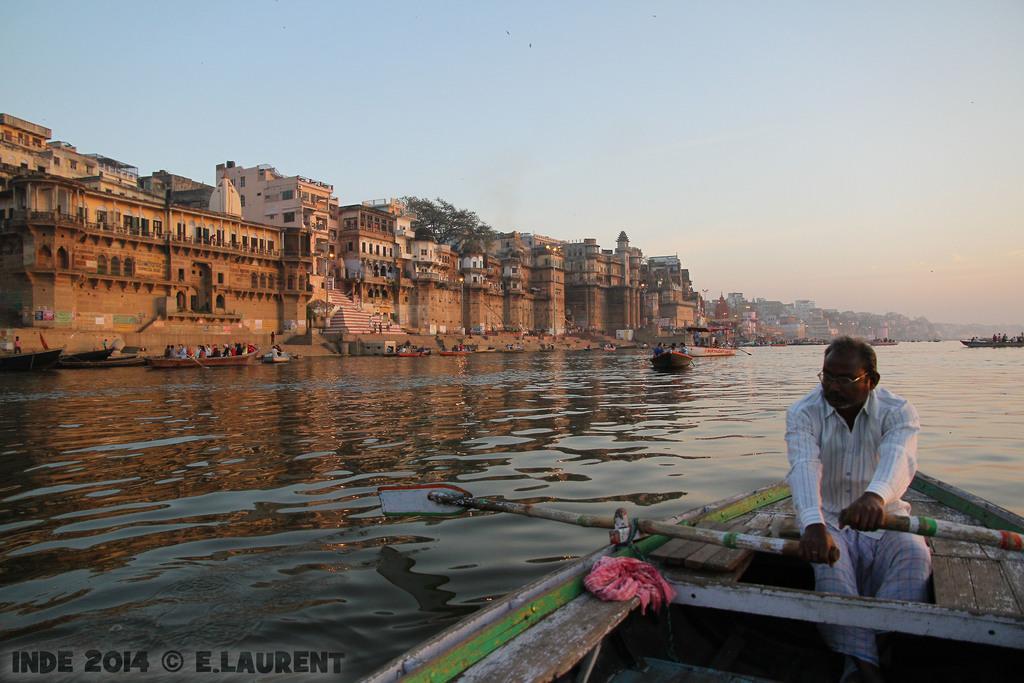Describe this image in one or two sentences. In this image I can see a person wearing white shirt, white pant is sitting on a boat and holding paddles in his hands. I can see a red colored cloth on the boat. In the background I can see the water, few boats in the water, few buildings, few trees and the sky. 